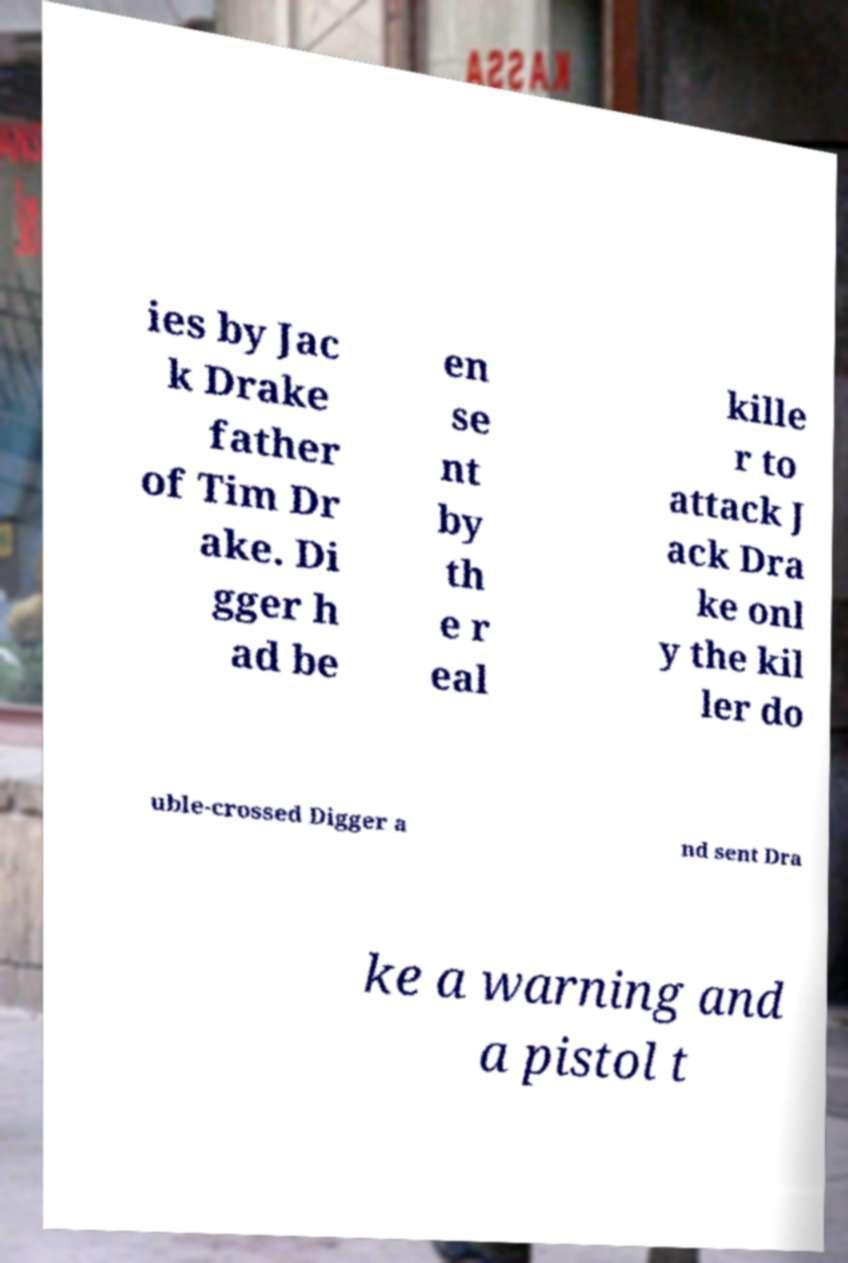There's text embedded in this image that I need extracted. Can you transcribe it verbatim? ies by Jac k Drake father of Tim Dr ake. Di gger h ad be en se nt by th e r eal kille r to attack J ack Dra ke onl y the kil ler do uble-crossed Digger a nd sent Dra ke a warning and a pistol t 